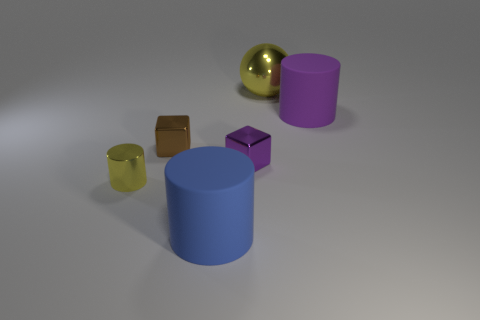What shapes and colors are present in this image? The image displays geometric shapes of various colors including a large yellow sphere, a big blue cylinder, a small purple cube, a small brown cube, and a small yellowish-green cylinder. 